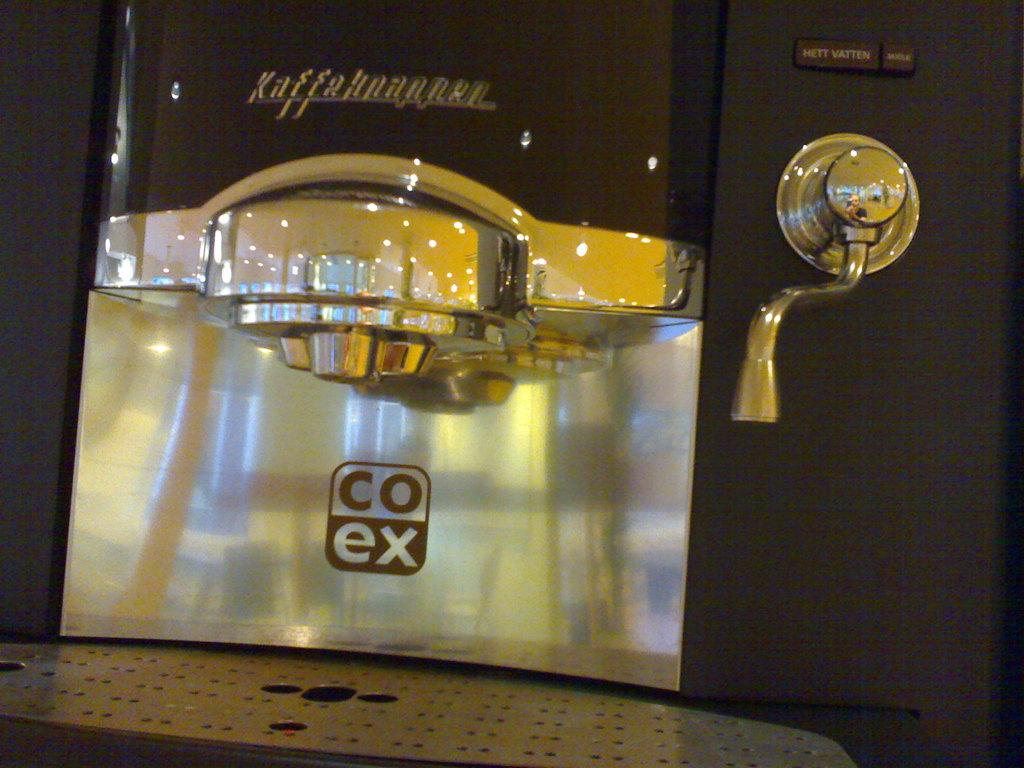<image>
Describe the image concisely. an object that is silver with co ex written on it 